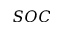Convert formula to latex. <formula><loc_0><loc_0><loc_500><loc_500>S O C</formula> 